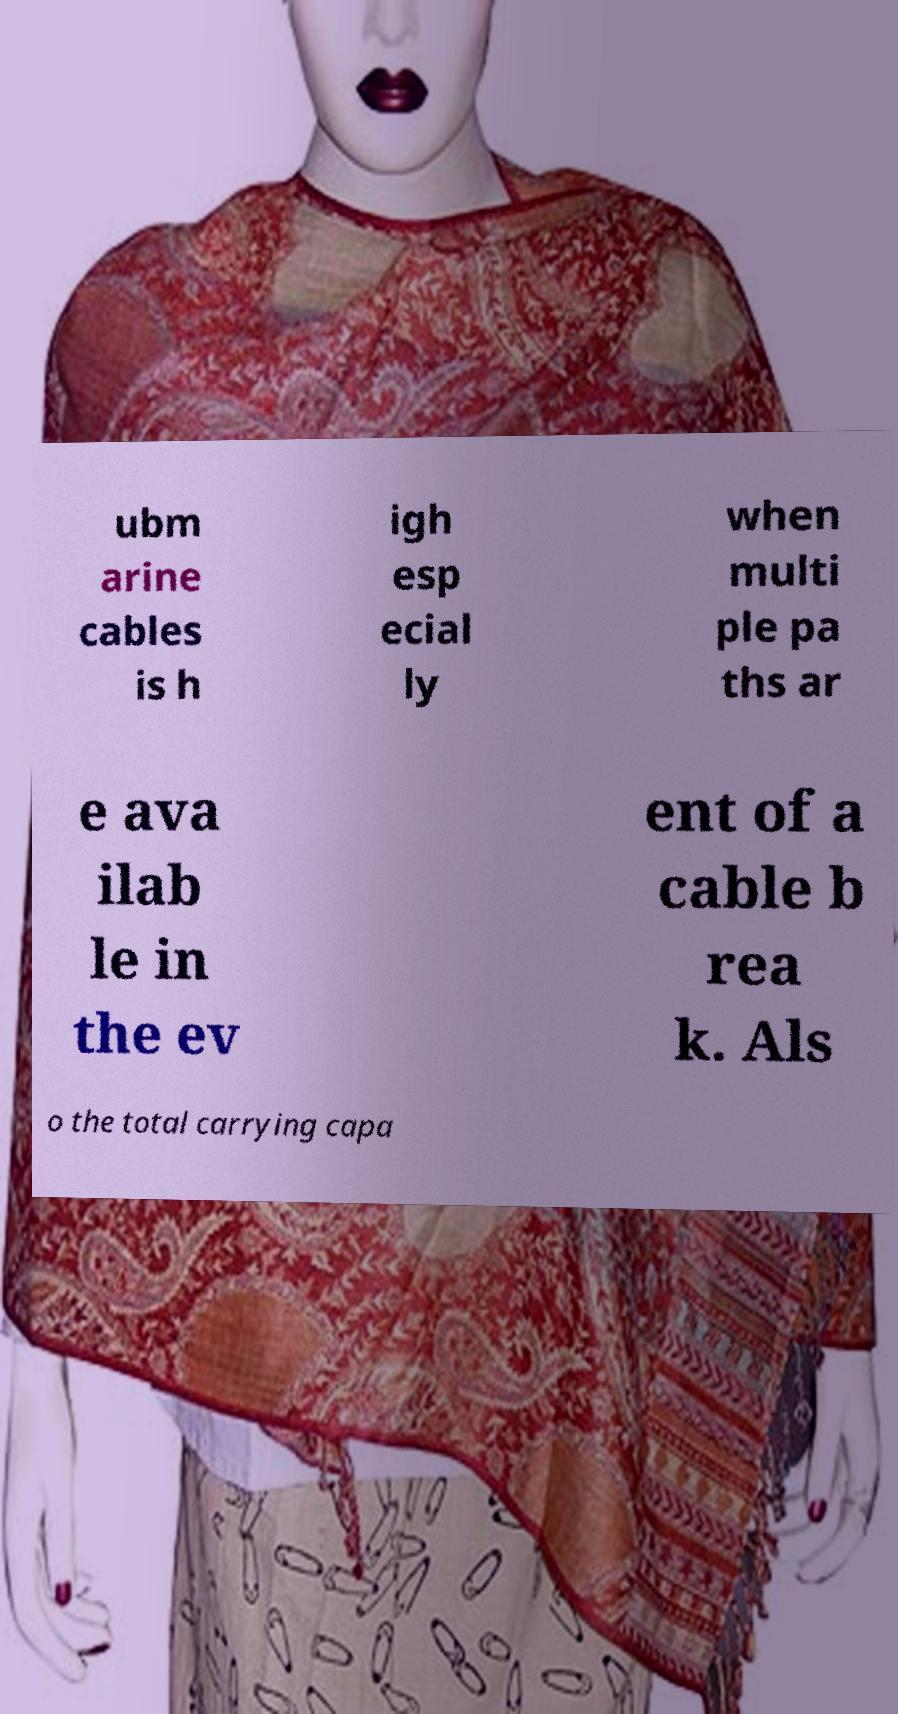There's text embedded in this image that I need extracted. Can you transcribe it verbatim? ubm arine cables is h igh esp ecial ly when multi ple pa ths ar e ava ilab le in the ev ent of a cable b rea k. Als o the total carrying capa 